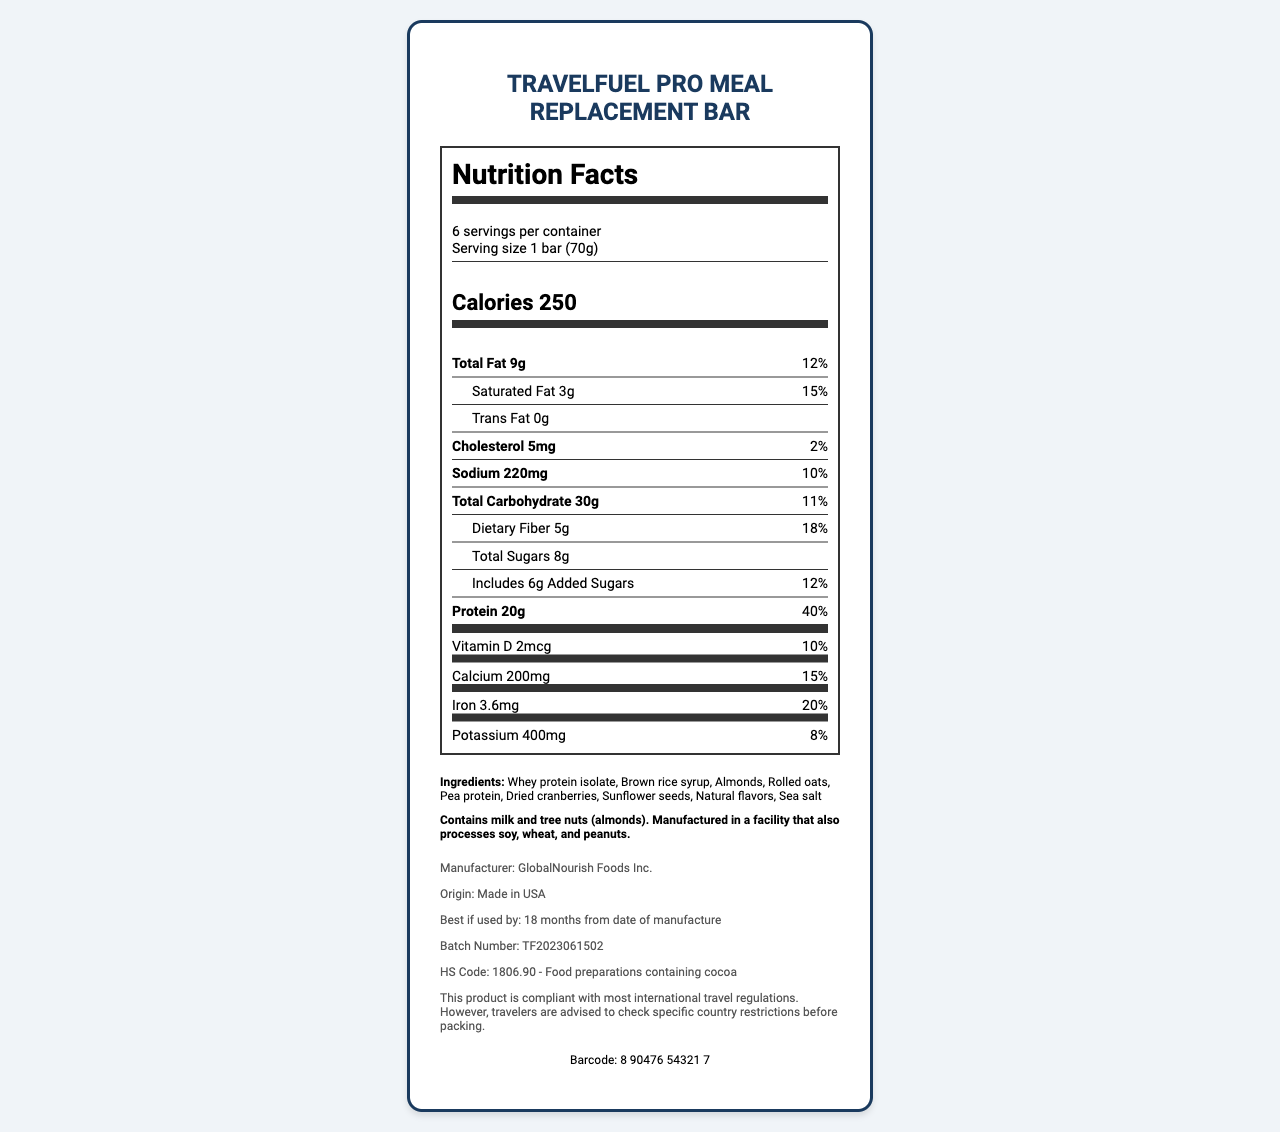how many servings are in the container? The document shows "6 servings per container" in the serving information section.
Answer: 6 servings what is the serving size for the TravelFuel Pro Meal Replacement Bar? The serving size is mentioned as "1 bar (70g)" in the serving information section.
Answer: 1 bar (70g) how many calories are in one serving of the protein bar? The document lists the caloric content as "Calories 250".
Answer: 250 calories what is the amount of total fat in one serving? "Total Fat 9g" is stated in the nutrient information section.
Answer: 9g what percentage of the daily value for protein does one serving provide? The document states "Protein 20g" and "40%" next to it, indicating the daily value percentage.
Answer: 40% how many grams of dietary fiber are there per serving? The dietary fiber content is listed as "Dietary Fiber 5g".
Answer: 5g what is the sodium content in one serving? The nutrient information states "Sodium 220mg".
Answer: 220mg what is the percentage of daily value for calcium in one serving? A. 10% B. 12% C. 15% The document lists "Calcium 200mg" with "15%" daily value next to it.
Answer: C. 15% which ingredient is not listed as part of the TravelFuel Pro Meal Replacement Bar? I. Whey protein isolate II. Sea salt III. Soy protein IV. Dried cranberries The ingredient list includes whey protein isolate, sea salt, and dried cranberries, but not soy protein.
Answer: III. Soy protein does the TravelFuel Pro Meal Replacement Bar contain any allergens? The allergen information section states the bar contains milk and tree nuts (almonds).
Answer: Yes what is the total amount of sugars in one serving, including added sugars? The document lists "Total Sugars 8g" and specifies "Includes 6g Added Sugars".
Answer: 8g (6g added sugars) how is the TravelFuel Pro Meal Replacement Bar compliant regarding international travel? The travel advisory section mentions this compliance and advisory.
Answer: The product is compliant with most international travel regulations but advises checking specific country restrictions before packing. who is the manufacturer of the protein bar? The additional information section lists the manufacturer as GlobalNourish Foods Inc.
Answer: GlobalNourish Foods Inc. what is the protein bar’s HS Code for customs declaration? A. 1905.90 B. 1806.90 C. 1704.90 The customs declaration section lists "HS Code: 1806.90 - Food preparations containing cocoa".
Answer: B. 1806.90 by which date should the protein bar ideally be used? This information is provided in the expiration date section.
Answer: Best if used by: 18 months from date of manufacture describe the main idea of the document. It details various sections such as nutritional content, serving size, ingredients, allergens, the manufacturer, origin, expiry, batch number, barcode, customs, and travel compliance.
Answer: The document provides comprehensive information about the TravelFuel Pro Meal Replacement Bar, including its nutrition facts, ingredients, allergen information, manufacturer details, customs declaration, and a travel advisory. how many milligrams of potassium are in each bar? The document lists "Potassium 400mg" in the vitamin information section.
Answer: 400mg is the protein bar suitable for individuals with peanut allergies? The document mentions it is manufactured in a facility that also processes peanuts, but it doesn't specify cross-contamination safety.
Answer: Cannot be determined 